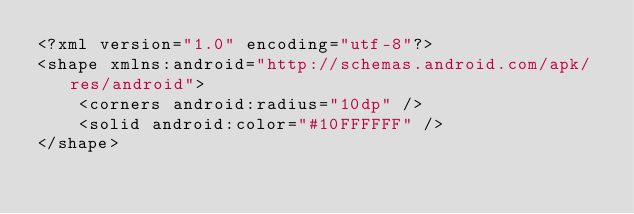<code> <loc_0><loc_0><loc_500><loc_500><_XML_><?xml version="1.0" encoding="utf-8"?>
<shape xmlns:android="http://schemas.android.com/apk/res/android">
    <corners android:radius="10dp" />
    <solid android:color="#10FFFFFF" />
</shape></code> 